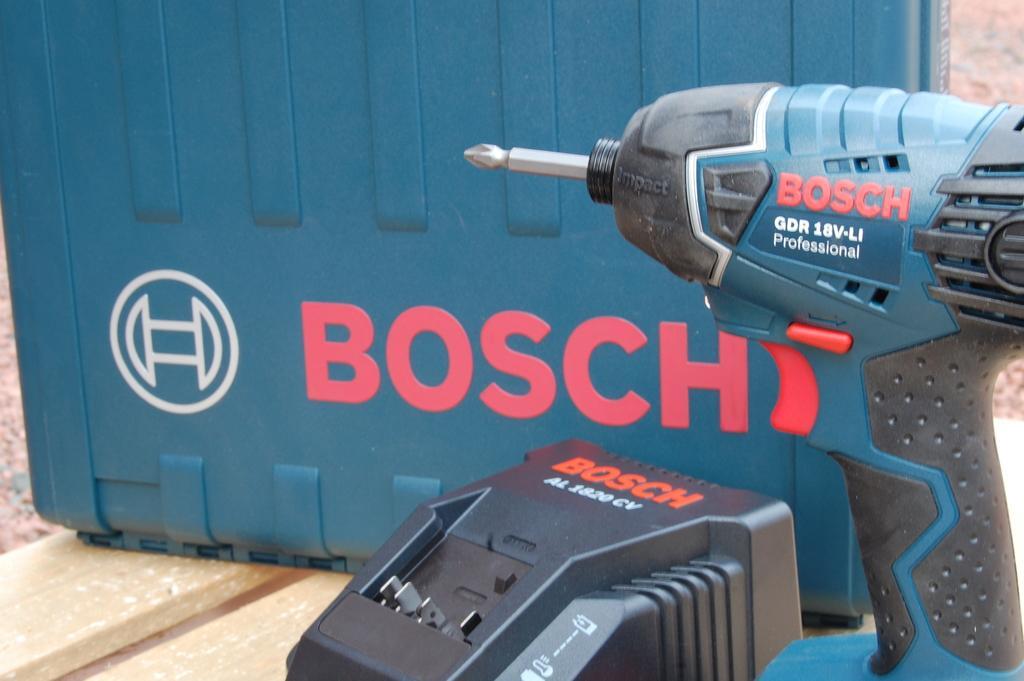Describe this image in one or two sentences. In this image there is a drilling machine, in front of the drilling machine there is other equipment. 